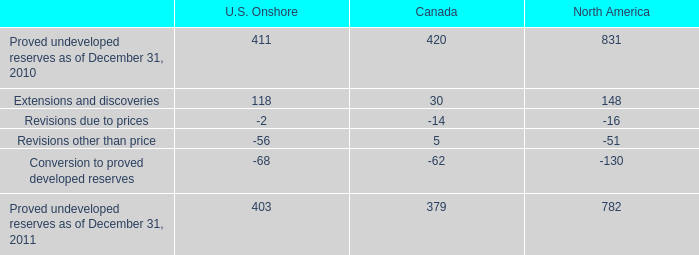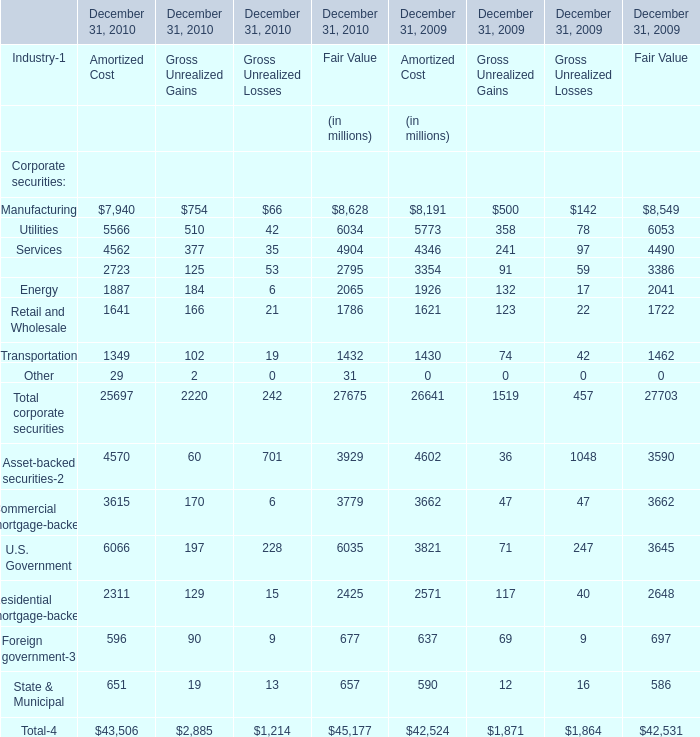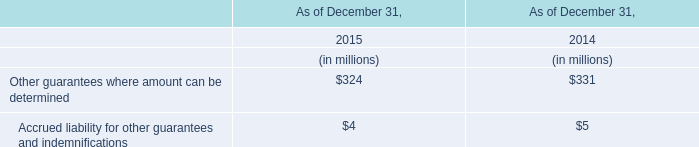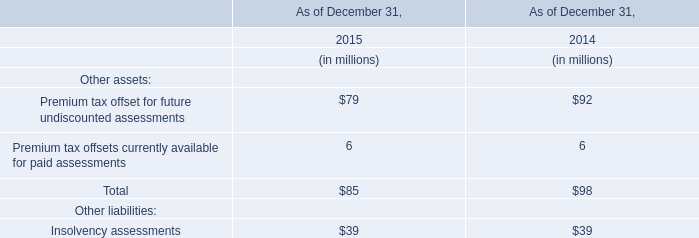In which year is Finance in fair value greater than 3000? 
Answer: 2009. 